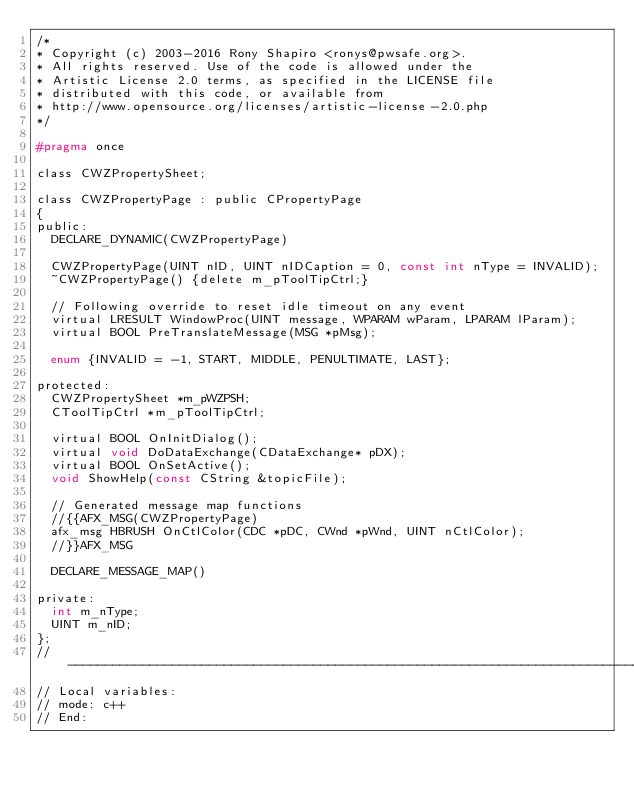<code> <loc_0><loc_0><loc_500><loc_500><_C_>/*
* Copyright (c) 2003-2016 Rony Shapiro <ronys@pwsafe.org>.
* All rights reserved. Use of the code is allowed under the
* Artistic License 2.0 terms, as specified in the LICENSE file
* distributed with this code, or available from
* http://www.opensource.org/licenses/artistic-license-2.0.php
*/

#pragma once

class CWZPropertySheet;

class CWZPropertyPage : public CPropertyPage
{
public:
  DECLARE_DYNAMIC(CWZPropertyPage)

  CWZPropertyPage(UINT nID, UINT nIDCaption = 0, const int nType = INVALID);
  ~CWZPropertyPage() {delete m_pToolTipCtrl;}

  // Following override to reset idle timeout on any event
  virtual LRESULT WindowProc(UINT message, WPARAM wParam, LPARAM lParam);
  virtual BOOL PreTranslateMessage(MSG *pMsg);

  enum {INVALID = -1, START, MIDDLE, PENULTIMATE, LAST};

protected:
  CWZPropertySheet *m_pWZPSH;
  CToolTipCtrl *m_pToolTipCtrl;

  virtual BOOL OnInitDialog();
  virtual void DoDataExchange(CDataExchange* pDX);
  virtual BOOL OnSetActive();
  void ShowHelp(const CString &topicFile);

  // Generated message map functions
  //{{AFX_MSG(CWZPropertyPage)
  afx_msg HBRUSH OnCtlColor(CDC *pDC, CWnd *pWnd, UINT nCtlColor);
  //}}AFX_MSG

  DECLARE_MESSAGE_MAP()

private:
  int m_nType;
  UINT m_nID;
};
//-----------------------------------------------------------------------------
// Local variables:
// mode: c++
// End:
</code> 